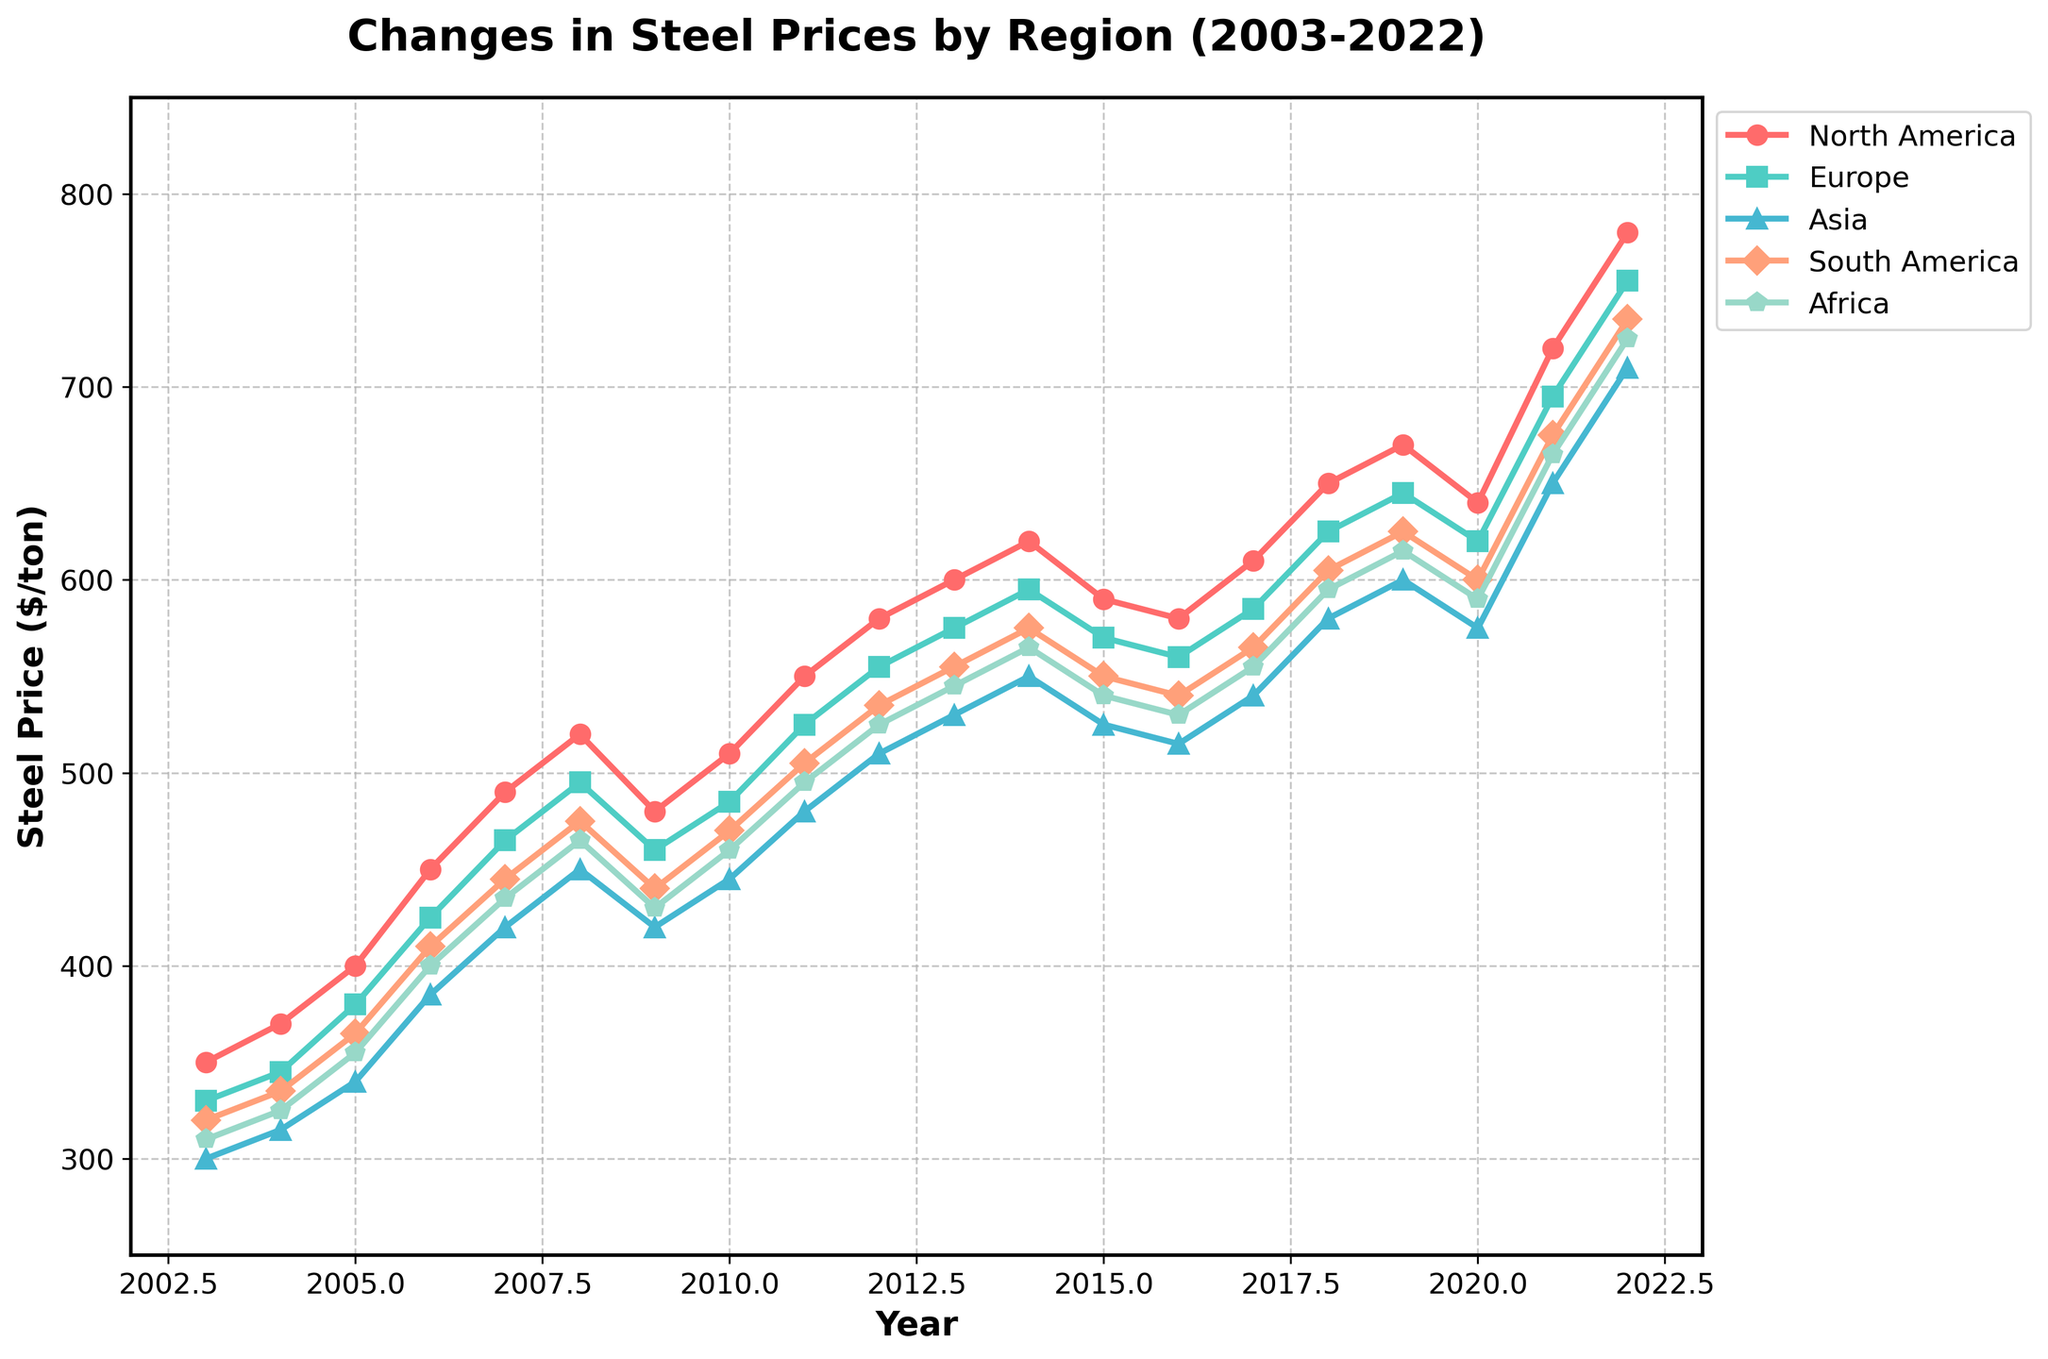What region experienced the highest steel price in 2022? Observe the plotted lines for 2022 and identify which one reaches the highest point on the Y-axis. The orange line (labeled 'North America') is the highest.
Answer: North America What is the range of steel prices in Asia from 2003 to 2022? Calculate the difference between the highest and lowest values in the Asia data series. The highest value is 710 in 2022, and the lowest value is 300 in 2003. Therefore, the range is 710 - 300.
Answer: 410 In which year did Europe and North America have the smallest difference in steel prices? Compare the differences between Europe and North America for each year by subtracting the European price from the North American price. The year with the smallest difference is 2019: 670 (North America) - 645 (Europe) = 25.
Answer: 2019 On average, which region had the highest steel prices over the past 20 years? Compute the average steel price for each region by summing their yearly values and dividing by the number of years (20). Compare the averages. North America has the highest average: (350+370+...+780)/20.
Answer: North America In which year did South America see the largest year-on-year increase in steel prices? Calculate the year-on-year differences for South America by subtracting the price of each year from the previous year. The largest increase occurred between 2020 and 2021: 675 - 600 = 75.
Answer: 2021 What's the average steel price difference between Europe and Asia from 2003 to 2022? For each year, subtract Asia's steel price from Europe's and compute the average of these yearly differences. The average difference is the sum of yearly differences divided by 20.
Answer: ~50 Which year had the most significant single-year drop in steel prices in North America? Calculate the differences in North America's prices for each year, noting the drop sizes. The largest drop occurs between 2019 and 2020: 670 - 640 = 30.
Answer: 2020 During which year did the steel price in Africa surpass that of Asia for the first time? Compare yearly prices for Africa and Asia. The first year Africa surpasses Asia is 2021: 665 (Africa) > 650 (Asia).
Answer: 2021 Which region had the most consistent steel price increase from 2003 to 2022 without any year-on-year declines? Check each region's year-on-year differences. North America consistently increases without falling in any year.
Answer: North America By how much did the steel price in Europe increase from 2003 to 2022, and what was the average annual growth rate? Determine the difference between 2022 and 2003 prices for Europe: 755 (2022) - 330 (2003) = 425. The average annual growth rate is 425/20 = 21.25 per year.
Answer: 425, 21.25 